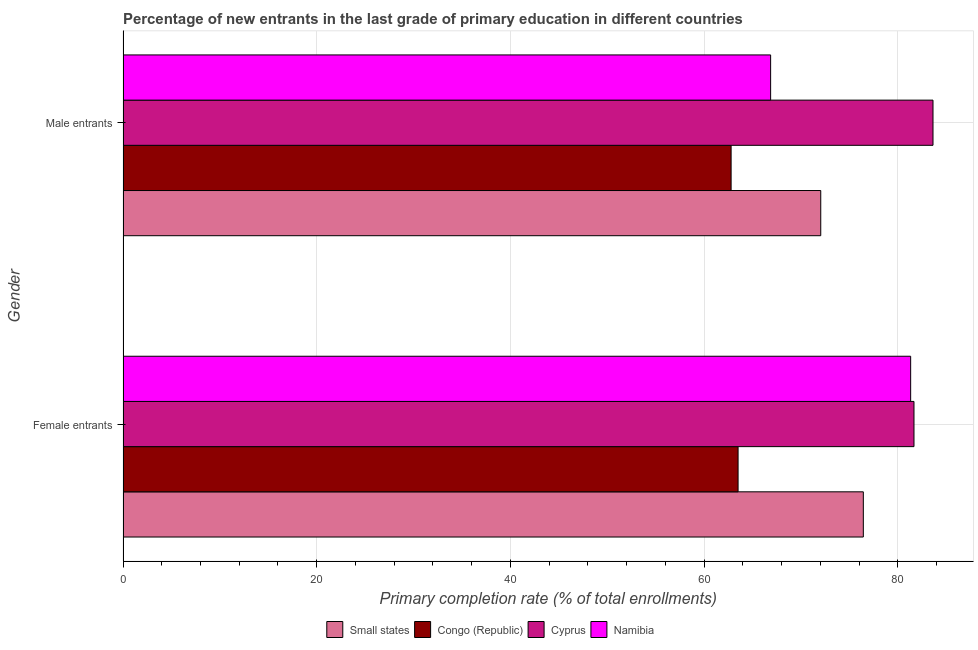How many bars are there on the 1st tick from the top?
Offer a terse response. 4. How many bars are there on the 2nd tick from the bottom?
Offer a very short reply. 4. What is the label of the 1st group of bars from the top?
Your answer should be very brief. Male entrants. What is the primary completion rate of female entrants in Congo (Republic)?
Provide a short and direct response. 63.51. Across all countries, what is the maximum primary completion rate of male entrants?
Your response must be concise. 83.63. Across all countries, what is the minimum primary completion rate of female entrants?
Offer a very short reply. 63.51. In which country was the primary completion rate of female entrants maximum?
Give a very brief answer. Cyprus. In which country was the primary completion rate of male entrants minimum?
Offer a terse response. Congo (Republic). What is the total primary completion rate of male entrants in the graph?
Keep it short and to the point. 285.32. What is the difference between the primary completion rate of female entrants in Small states and that in Cyprus?
Make the answer very short. -5.23. What is the difference between the primary completion rate of male entrants in Cyprus and the primary completion rate of female entrants in Small states?
Provide a short and direct response. 7.19. What is the average primary completion rate of male entrants per country?
Provide a short and direct response. 71.33. What is the difference between the primary completion rate of male entrants and primary completion rate of female entrants in Congo (Republic)?
Give a very brief answer. -0.72. What is the ratio of the primary completion rate of male entrants in Small states to that in Cyprus?
Your response must be concise. 0.86. What does the 4th bar from the top in Female entrants represents?
Ensure brevity in your answer.  Small states. What does the 2nd bar from the bottom in Male entrants represents?
Keep it short and to the point. Congo (Republic). How many bars are there?
Make the answer very short. 8. Are the values on the major ticks of X-axis written in scientific E-notation?
Make the answer very short. No. Does the graph contain grids?
Offer a very short reply. Yes. How are the legend labels stacked?
Offer a terse response. Horizontal. What is the title of the graph?
Your answer should be compact. Percentage of new entrants in the last grade of primary education in different countries. Does "New Caledonia" appear as one of the legend labels in the graph?
Offer a very short reply. No. What is the label or title of the X-axis?
Give a very brief answer. Primary completion rate (% of total enrollments). What is the label or title of the Y-axis?
Provide a succinct answer. Gender. What is the Primary completion rate (% of total enrollments) in Small states in Female entrants?
Your response must be concise. 76.44. What is the Primary completion rate (% of total enrollments) of Congo (Republic) in Female entrants?
Make the answer very short. 63.51. What is the Primary completion rate (% of total enrollments) in Cyprus in Female entrants?
Give a very brief answer. 81.67. What is the Primary completion rate (% of total enrollments) of Namibia in Female entrants?
Offer a terse response. 81.32. What is the Primary completion rate (% of total enrollments) in Small states in Male entrants?
Ensure brevity in your answer.  72.04. What is the Primary completion rate (% of total enrollments) of Congo (Republic) in Male entrants?
Your answer should be compact. 62.79. What is the Primary completion rate (% of total enrollments) of Cyprus in Male entrants?
Your response must be concise. 83.63. What is the Primary completion rate (% of total enrollments) of Namibia in Male entrants?
Offer a very short reply. 66.87. Across all Gender, what is the maximum Primary completion rate (% of total enrollments) of Small states?
Provide a short and direct response. 76.44. Across all Gender, what is the maximum Primary completion rate (% of total enrollments) of Congo (Republic)?
Provide a short and direct response. 63.51. Across all Gender, what is the maximum Primary completion rate (% of total enrollments) of Cyprus?
Keep it short and to the point. 83.63. Across all Gender, what is the maximum Primary completion rate (% of total enrollments) of Namibia?
Your response must be concise. 81.32. Across all Gender, what is the minimum Primary completion rate (% of total enrollments) in Small states?
Ensure brevity in your answer.  72.04. Across all Gender, what is the minimum Primary completion rate (% of total enrollments) in Congo (Republic)?
Provide a succinct answer. 62.79. Across all Gender, what is the minimum Primary completion rate (% of total enrollments) in Cyprus?
Make the answer very short. 81.67. Across all Gender, what is the minimum Primary completion rate (% of total enrollments) in Namibia?
Provide a succinct answer. 66.87. What is the total Primary completion rate (% of total enrollments) in Small states in the graph?
Ensure brevity in your answer.  148.48. What is the total Primary completion rate (% of total enrollments) in Congo (Republic) in the graph?
Offer a very short reply. 126.29. What is the total Primary completion rate (% of total enrollments) of Cyprus in the graph?
Offer a terse response. 165.3. What is the total Primary completion rate (% of total enrollments) of Namibia in the graph?
Your response must be concise. 148.19. What is the difference between the Primary completion rate (% of total enrollments) of Small states in Female entrants and that in Male entrants?
Your answer should be very brief. 4.4. What is the difference between the Primary completion rate (% of total enrollments) in Congo (Republic) in Female entrants and that in Male entrants?
Your answer should be very brief. 0.72. What is the difference between the Primary completion rate (% of total enrollments) in Cyprus in Female entrants and that in Male entrants?
Your answer should be compact. -1.96. What is the difference between the Primary completion rate (% of total enrollments) in Namibia in Female entrants and that in Male entrants?
Your answer should be compact. 14.46. What is the difference between the Primary completion rate (% of total enrollments) in Small states in Female entrants and the Primary completion rate (% of total enrollments) in Congo (Republic) in Male entrants?
Offer a very short reply. 13.65. What is the difference between the Primary completion rate (% of total enrollments) of Small states in Female entrants and the Primary completion rate (% of total enrollments) of Cyprus in Male entrants?
Offer a very short reply. -7.19. What is the difference between the Primary completion rate (% of total enrollments) of Small states in Female entrants and the Primary completion rate (% of total enrollments) of Namibia in Male entrants?
Offer a terse response. 9.57. What is the difference between the Primary completion rate (% of total enrollments) in Congo (Republic) in Female entrants and the Primary completion rate (% of total enrollments) in Cyprus in Male entrants?
Provide a succinct answer. -20.12. What is the difference between the Primary completion rate (% of total enrollments) of Congo (Republic) in Female entrants and the Primary completion rate (% of total enrollments) of Namibia in Male entrants?
Your answer should be very brief. -3.36. What is the difference between the Primary completion rate (% of total enrollments) of Cyprus in Female entrants and the Primary completion rate (% of total enrollments) of Namibia in Male entrants?
Keep it short and to the point. 14.8. What is the average Primary completion rate (% of total enrollments) of Small states per Gender?
Give a very brief answer. 74.24. What is the average Primary completion rate (% of total enrollments) of Congo (Republic) per Gender?
Your answer should be compact. 63.15. What is the average Primary completion rate (% of total enrollments) of Cyprus per Gender?
Your response must be concise. 82.65. What is the average Primary completion rate (% of total enrollments) in Namibia per Gender?
Offer a terse response. 74.09. What is the difference between the Primary completion rate (% of total enrollments) in Small states and Primary completion rate (% of total enrollments) in Congo (Republic) in Female entrants?
Your answer should be very brief. 12.93. What is the difference between the Primary completion rate (% of total enrollments) of Small states and Primary completion rate (% of total enrollments) of Cyprus in Female entrants?
Give a very brief answer. -5.23. What is the difference between the Primary completion rate (% of total enrollments) in Small states and Primary completion rate (% of total enrollments) in Namibia in Female entrants?
Ensure brevity in your answer.  -4.89. What is the difference between the Primary completion rate (% of total enrollments) in Congo (Republic) and Primary completion rate (% of total enrollments) in Cyprus in Female entrants?
Provide a succinct answer. -18.16. What is the difference between the Primary completion rate (% of total enrollments) of Congo (Republic) and Primary completion rate (% of total enrollments) of Namibia in Female entrants?
Your answer should be very brief. -17.82. What is the difference between the Primary completion rate (% of total enrollments) in Cyprus and Primary completion rate (% of total enrollments) in Namibia in Female entrants?
Offer a terse response. 0.34. What is the difference between the Primary completion rate (% of total enrollments) of Small states and Primary completion rate (% of total enrollments) of Congo (Republic) in Male entrants?
Offer a very short reply. 9.26. What is the difference between the Primary completion rate (% of total enrollments) of Small states and Primary completion rate (% of total enrollments) of Cyprus in Male entrants?
Your response must be concise. -11.59. What is the difference between the Primary completion rate (% of total enrollments) of Small states and Primary completion rate (% of total enrollments) of Namibia in Male entrants?
Provide a succinct answer. 5.18. What is the difference between the Primary completion rate (% of total enrollments) in Congo (Republic) and Primary completion rate (% of total enrollments) in Cyprus in Male entrants?
Your answer should be very brief. -20.84. What is the difference between the Primary completion rate (% of total enrollments) of Congo (Republic) and Primary completion rate (% of total enrollments) of Namibia in Male entrants?
Make the answer very short. -4.08. What is the difference between the Primary completion rate (% of total enrollments) of Cyprus and Primary completion rate (% of total enrollments) of Namibia in Male entrants?
Offer a very short reply. 16.76. What is the ratio of the Primary completion rate (% of total enrollments) in Small states in Female entrants to that in Male entrants?
Offer a very short reply. 1.06. What is the ratio of the Primary completion rate (% of total enrollments) in Congo (Republic) in Female entrants to that in Male entrants?
Ensure brevity in your answer.  1.01. What is the ratio of the Primary completion rate (% of total enrollments) in Cyprus in Female entrants to that in Male entrants?
Make the answer very short. 0.98. What is the ratio of the Primary completion rate (% of total enrollments) of Namibia in Female entrants to that in Male entrants?
Offer a very short reply. 1.22. What is the difference between the highest and the second highest Primary completion rate (% of total enrollments) in Small states?
Keep it short and to the point. 4.4. What is the difference between the highest and the second highest Primary completion rate (% of total enrollments) in Congo (Republic)?
Your answer should be compact. 0.72. What is the difference between the highest and the second highest Primary completion rate (% of total enrollments) of Cyprus?
Offer a terse response. 1.96. What is the difference between the highest and the second highest Primary completion rate (% of total enrollments) in Namibia?
Offer a very short reply. 14.46. What is the difference between the highest and the lowest Primary completion rate (% of total enrollments) of Small states?
Provide a short and direct response. 4.4. What is the difference between the highest and the lowest Primary completion rate (% of total enrollments) in Congo (Republic)?
Give a very brief answer. 0.72. What is the difference between the highest and the lowest Primary completion rate (% of total enrollments) of Cyprus?
Provide a succinct answer. 1.96. What is the difference between the highest and the lowest Primary completion rate (% of total enrollments) in Namibia?
Make the answer very short. 14.46. 